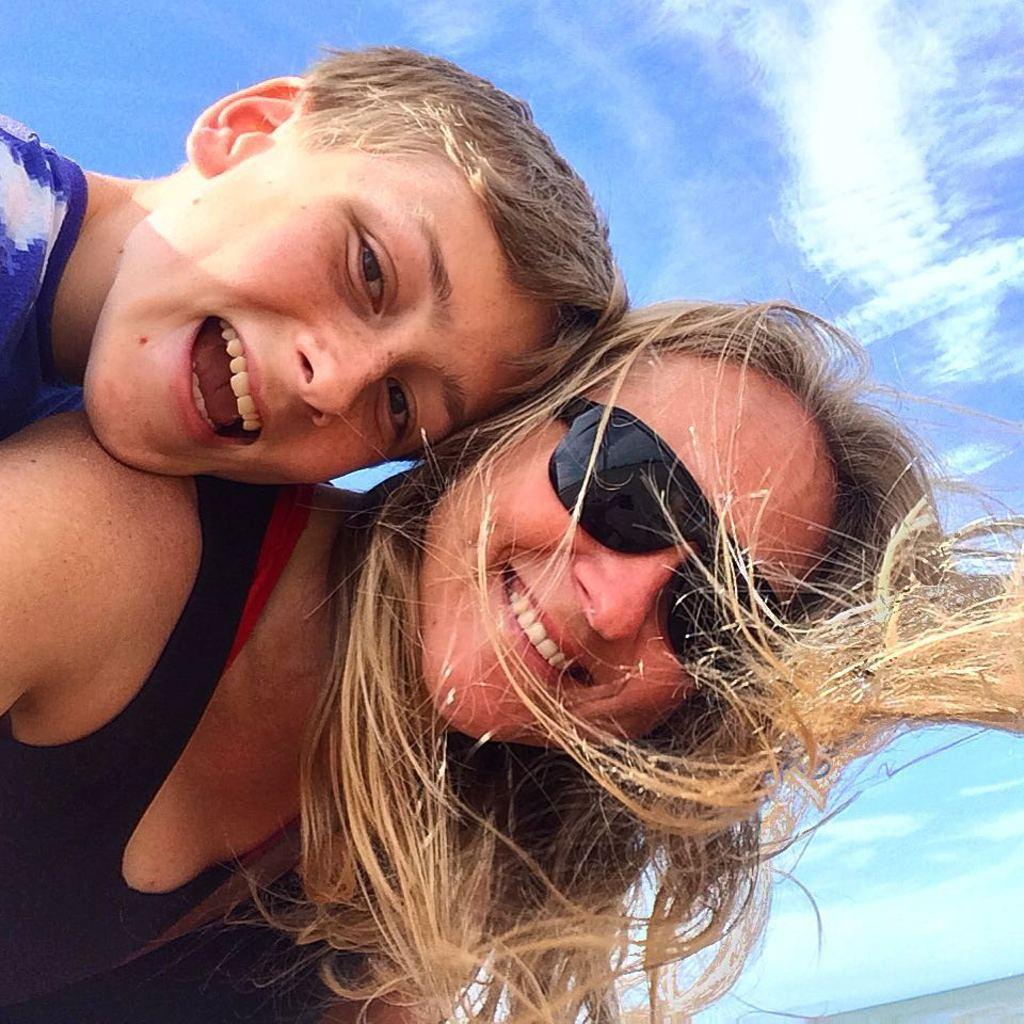Who are the people in the image? There is a woman and a boy in the image. What are the expressions on their faces? The woman and the boy are both smiling. What can be seen in the sky in the image? There are clouds in the sky. What type of station is visible in the image? There is no station present in the image. Is there a beggar asking for money in the image? There is no beggar present in the image. 